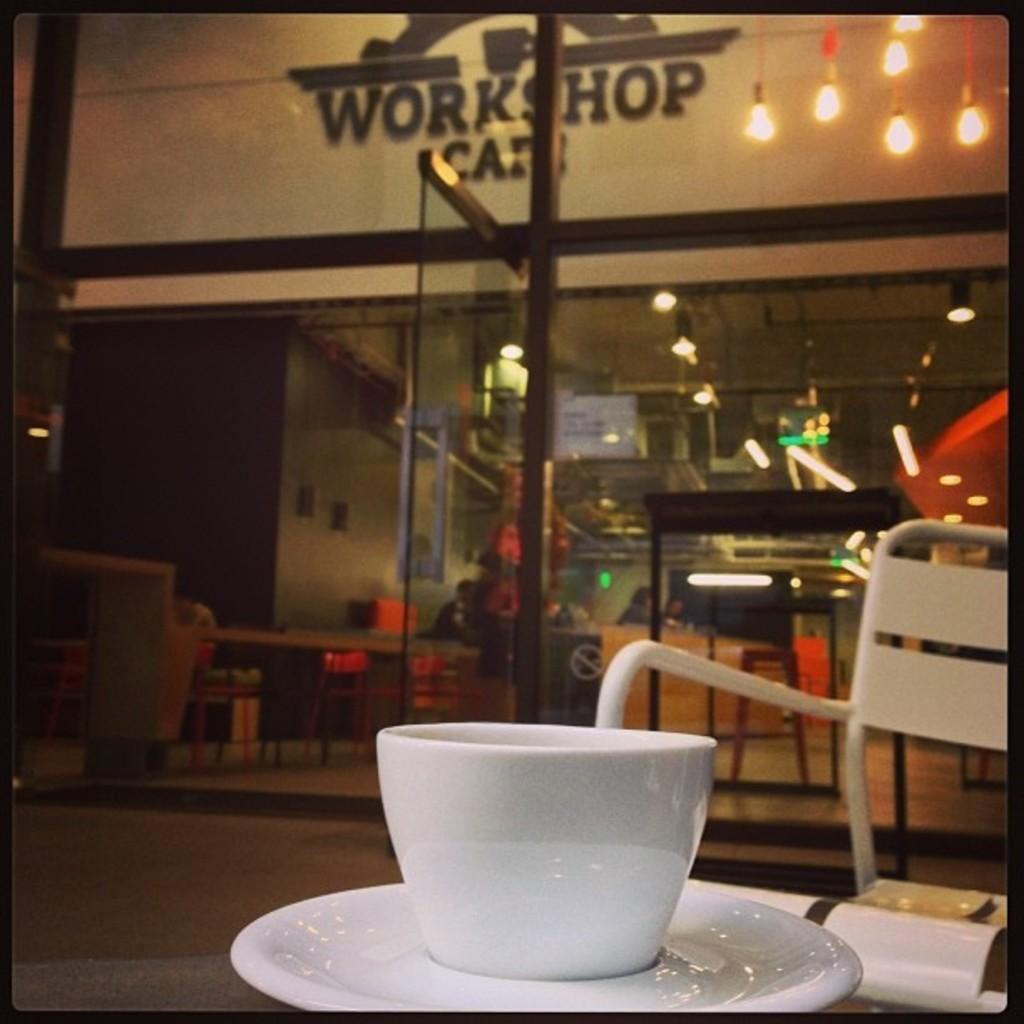<image>
Describe the image concisely. A white ceramic cup sits in front of big glass doors at the Workshop Cafe. 